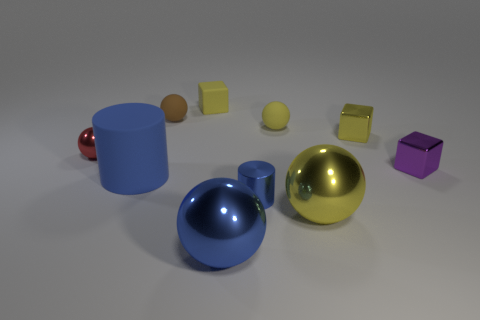Is there a tiny rubber thing that has the same shape as the red shiny thing?
Your answer should be compact. Yes. What number of small brown rubber things are the same shape as the small blue thing?
Give a very brief answer. 0. Is the color of the tiny metal cylinder the same as the big cylinder?
Ensure brevity in your answer.  Yes. Are there fewer yellow metallic balls than small metal things?
Offer a very short reply. Yes. There is a blue cylinder that is on the left side of the rubber cube; what is it made of?
Your response must be concise. Rubber. What material is the blue cylinder that is the same size as the purple cube?
Your response must be concise. Metal. What is the large blue thing in front of the yellow ball that is in front of the small metallic thing left of the big matte cylinder made of?
Your response must be concise. Metal. There is a yellow sphere behind the metal cylinder; is its size the same as the big rubber cylinder?
Make the answer very short. No. Are there more blue metallic objects than large brown objects?
Keep it short and to the point. Yes. How many small objects are cubes or blue rubber things?
Provide a short and direct response. 3. 